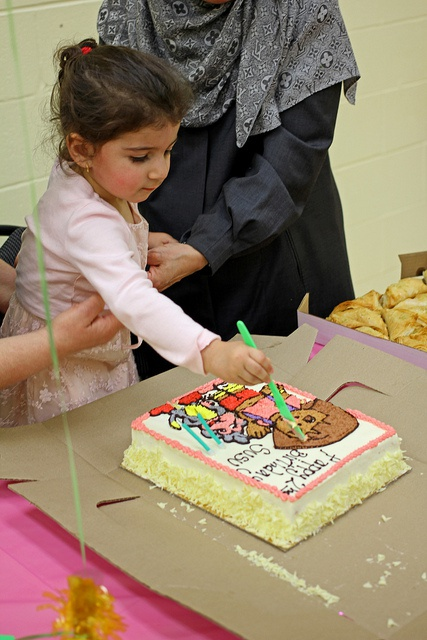Describe the objects in this image and their specific colors. I can see dining table in tan, khaki, and violet tones, people in tan, black, and gray tones, people in tan, lightgray, black, gray, and darkgray tones, cake in tan, khaki, beige, and salmon tones, and people in tan, gray, and brown tones in this image. 